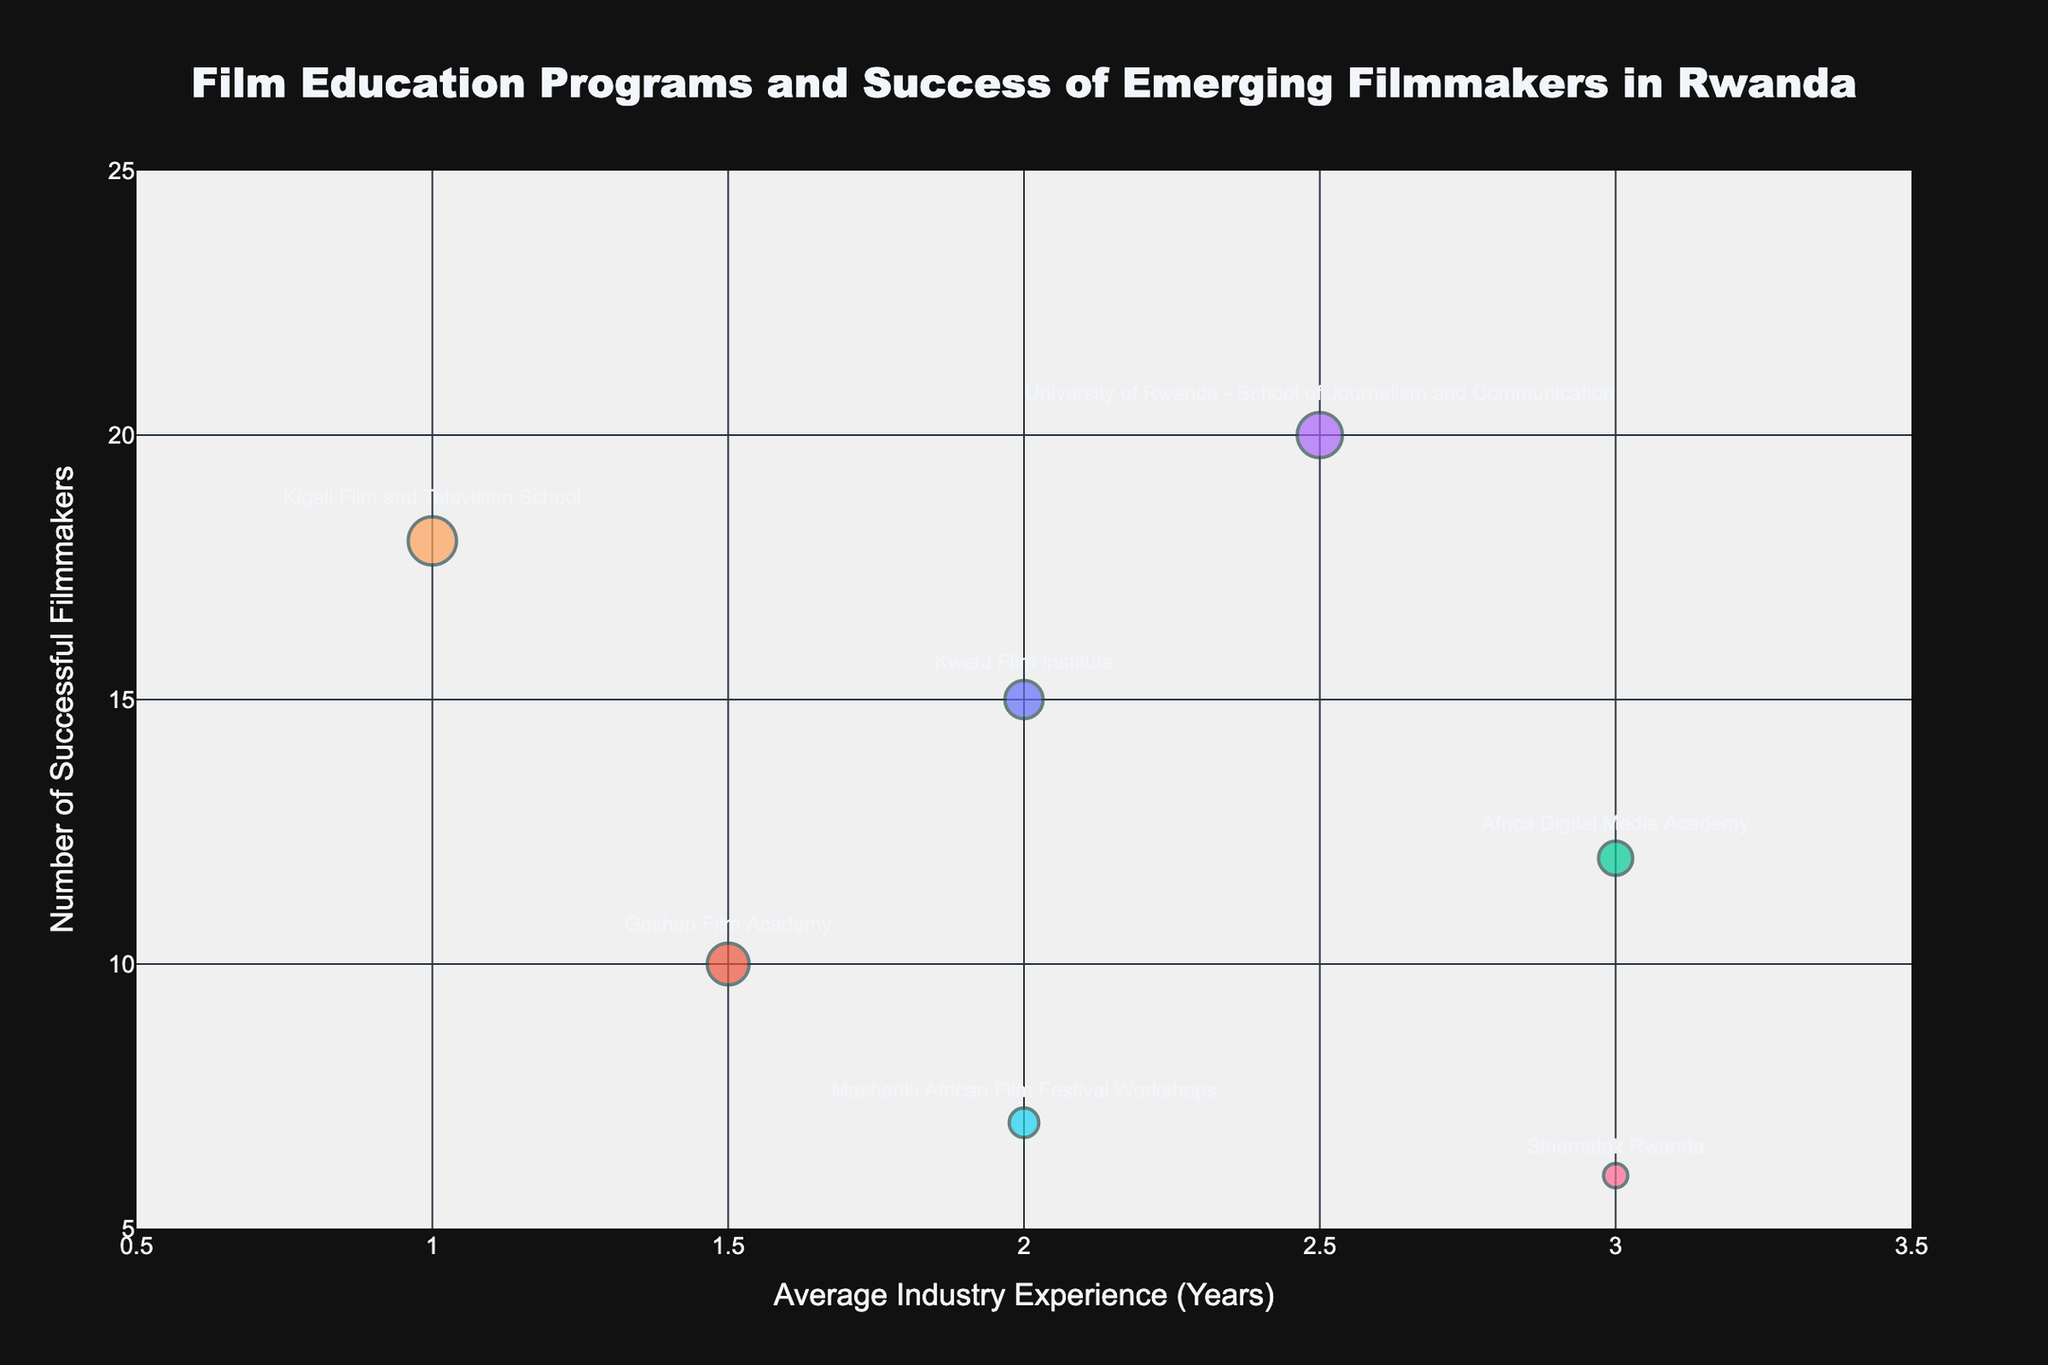What's the title of the chart? The title of the chart can be found at the top center of the figure in a large font size. The title is "Film Education Programs and Success of Emerging Filmmakers in Rwanda".
Answer: Film Education Programs and Success of Emerging Filmmakers in Rwanda What are the labels for the axes? The x-axis label is found below the horizontal axis and the y-axis label is found next to the vertical axis. The x-axis is labeled "Average Industry Experience (Years)" and the y-axis is labeled "Number of Successful Filmmakers".
Answer: Average Industry Experience (Years), Number of Successful Filmmakers Which program has the most number of graduates? By looking at the size of the bubbles, which represents the number of graduates, we can see which bubble is the largest. Kigali Film and Television School has the largest bubble indicating the most number of graduates.
Answer: Kigali Film and Television School Which program has the highest number of successful filmmakers? The y-axis represents the number of successful filmmakers. The program with the highest point on the y-axis has the most successful filmmakers. University of Rwanda - School of Journalism and Communication has the highest position on the y-axis.
Answer: University of Rwanda - School of Journalism and Communication What is the range of the average industry experience shown on the x-axis? The x-axis range can be determined by looking at the lowest and highest values on the axis. The range for average industry experience is from 0.5 to 3.5 years.
Answer: 0.5 to 3.5 years How many programs have an average industry experience of more than 2 years? To answer this, identify the bubbles positioned right of the 2-year mark on the x-axis. Kwetu Film Institute, Africa Digital Media Academy, University of Rwanda - School of Journalism and Communication, Sinematek Rwanda, and Mashariki African Film Festival Workshops, making a total of 5 programs fall into this category.
Answer: 5 programs Which program has the smallest number of successful filmmakers and how much average industry experience do they offer? The program with the bubble that is lowest on the y-axis has the smallest number of successful filmmakers. Sinematek Rwanda has the smallest number of successful filmmakers at 6 and offers an average industry experience of 3 years.
Answer: Sinematek Rwanda, 3 years Compare the number of successful filmmakers between the Kwetu Film Institute and the Goshen Film Academy. Which one has more? The number of successful filmmakers is indicated by the position on the y-axis. Kwetu Film Institute has 15 successful filmmakers while Goshen Film Academy has 10. Therefore, Kwetu Film Institute has more successful filmmakers.
Answer: Kwetu Film Institute Which program has the greatest number of successful filmmakers relative to the number of graduates? To find this, compare the ratio of successful filmmakers to the number of graduates for each program. University of Rwanda - School of Journalism and Communication has 20 successful filmmakers out of 35 graduates, making it the highest at approximately 0.57.
Answer: University of Rwanda - School of Journalism and Communication 